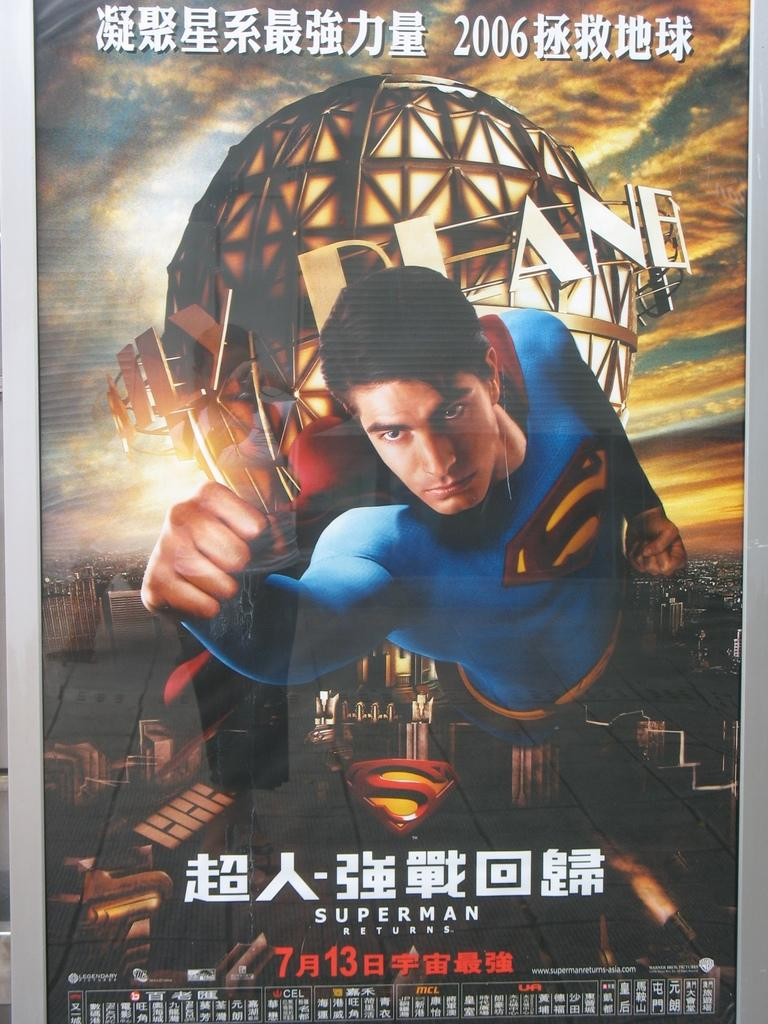<image>
Describe the image concisely. a superman movie poster has him flying in front of the daily planet 